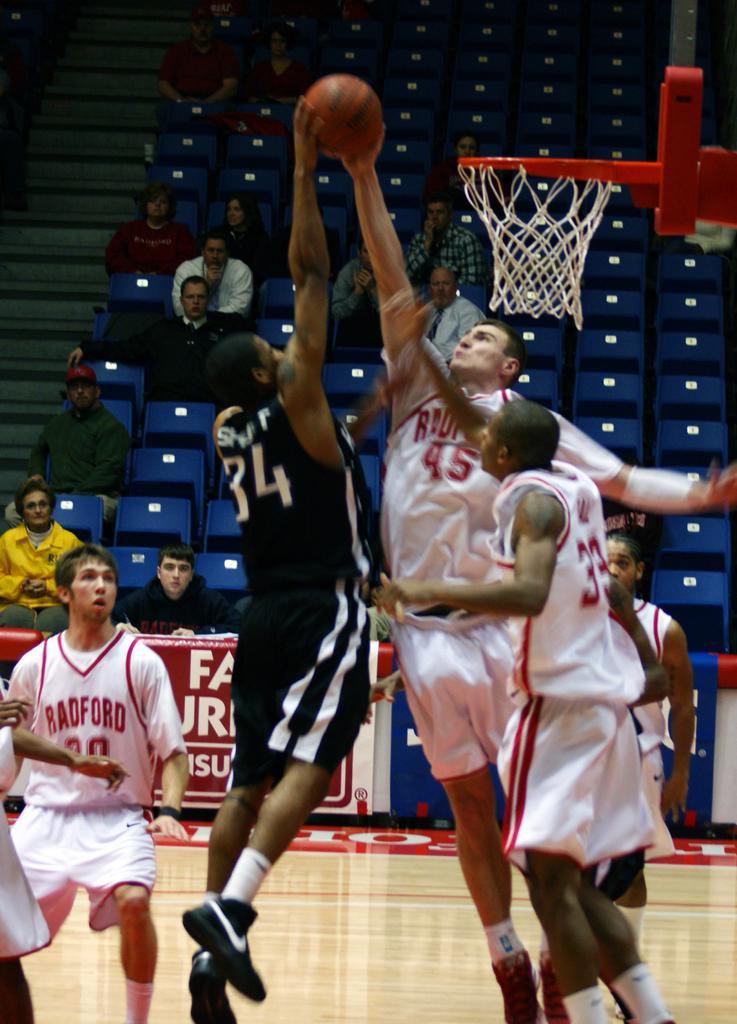In one or two sentences, can you explain what this image depicts? In the foreground of this image, there are few persons playing basket in the court and in the background, there are chairs, stairs, and few persons siting. 